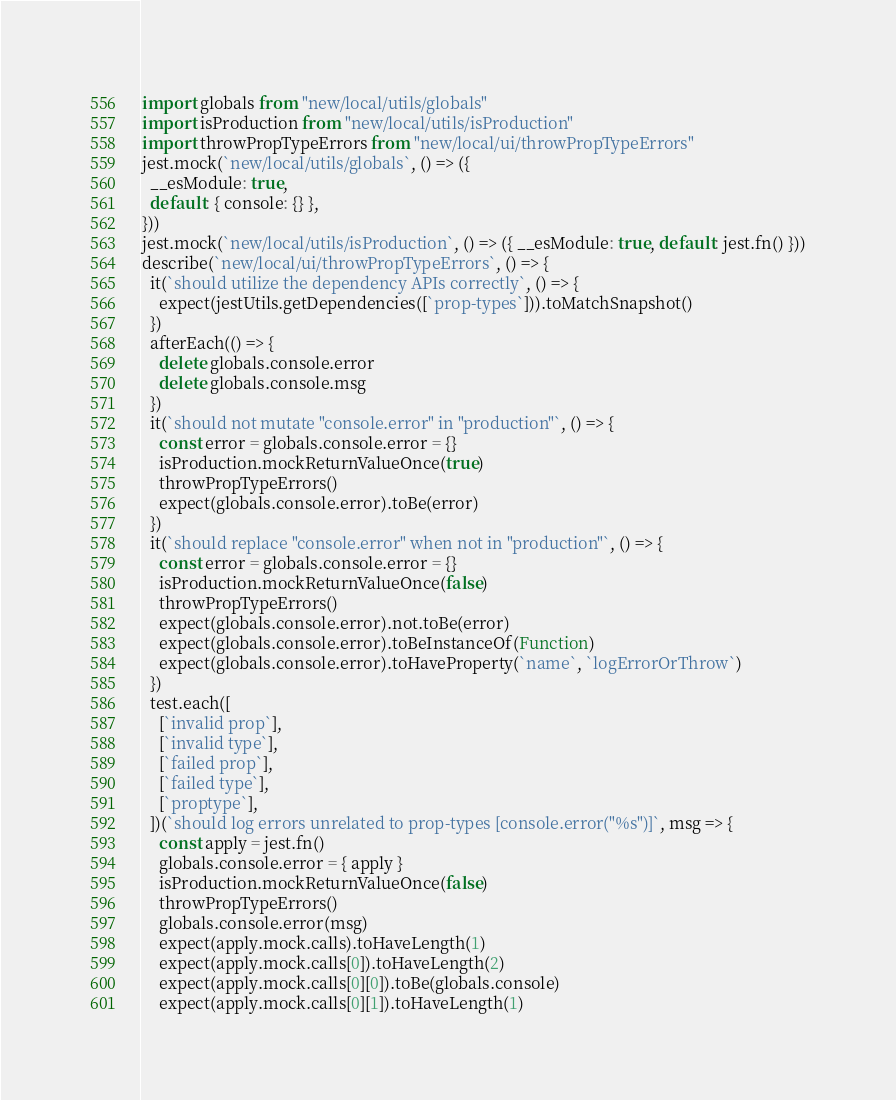<code> <loc_0><loc_0><loc_500><loc_500><_JavaScript_>import globals from "new/local/utils/globals"
import isProduction from "new/local/utils/isProduction"
import throwPropTypeErrors from "new/local/ui/throwPropTypeErrors"
jest.mock(`new/local/utils/globals`, () => ({
  __esModule: true,
  default: { console: {} },
}))
jest.mock(`new/local/utils/isProduction`, () => ({ __esModule: true, default: jest.fn() }))
describe(`new/local/ui/throwPropTypeErrors`, () => {
  it(`should utilize the dependency APIs correctly`, () => {
    expect(jestUtils.getDependencies([`prop-types`])).toMatchSnapshot()
  })
  afterEach(() => {
    delete globals.console.error
    delete globals.console.msg
  })
  it(`should not mutate "console.error" in "production"`, () => {
    const error = globals.console.error = {}
    isProduction.mockReturnValueOnce(true)
    throwPropTypeErrors()
    expect(globals.console.error).toBe(error)
  })
  it(`should replace "console.error" when not in "production"`, () => {
    const error = globals.console.error = {}
    isProduction.mockReturnValueOnce(false)
    throwPropTypeErrors()
    expect(globals.console.error).not.toBe(error)
    expect(globals.console.error).toBeInstanceOf(Function)
    expect(globals.console.error).toHaveProperty(`name`, `logErrorOrThrow`)
  })
  test.each([
    [`invalid prop`],
    [`invalid type`],
    [`failed prop`],
    [`failed type`],
    [`proptype`],
  ])(`should log errors unrelated to prop-types [console.error("%s")]`, msg => {
    const apply = jest.fn()
    globals.console.error = { apply }
    isProduction.mockReturnValueOnce(false)
    throwPropTypeErrors()
    globals.console.error(msg)
    expect(apply.mock.calls).toHaveLength(1)
    expect(apply.mock.calls[0]).toHaveLength(2)
    expect(apply.mock.calls[0][0]).toBe(globals.console)
    expect(apply.mock.calls[0][1]).toHaveLength(1)</code> 